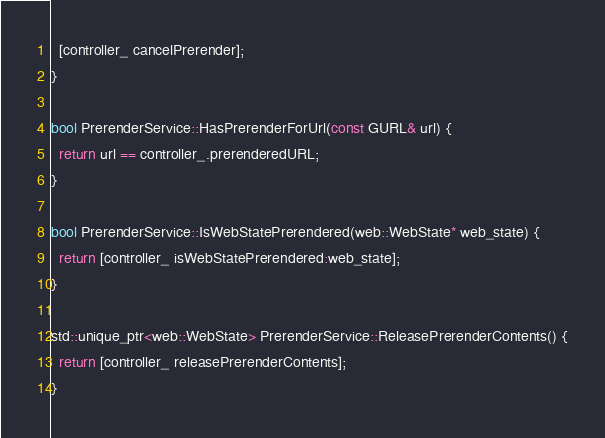<code> <loc_0><loc_0><loc_500><loc_500><_ObjectiveC_>  [controller_ cancelPrerender];
}

bool PrerenderService::HasPrerenderForUrl(const GURL& url) {
  return url == controller_.prerenderedURL;
}

bool PrerenderService::IsWebStatePrerendered(web::WebState* web_state) {
  return [controller_ isWebStatePrerendered:web_state];
}

std::unique_ptr<web::WebState> PrerenderService::ReleasePrerenderContents() {
  return [controller_ releasePrerenderContents];
}
</code> 